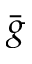Convert formula to latex. <formula><loc_0><loc_0><loc_500><loc_500>\bar { g }</formula> 